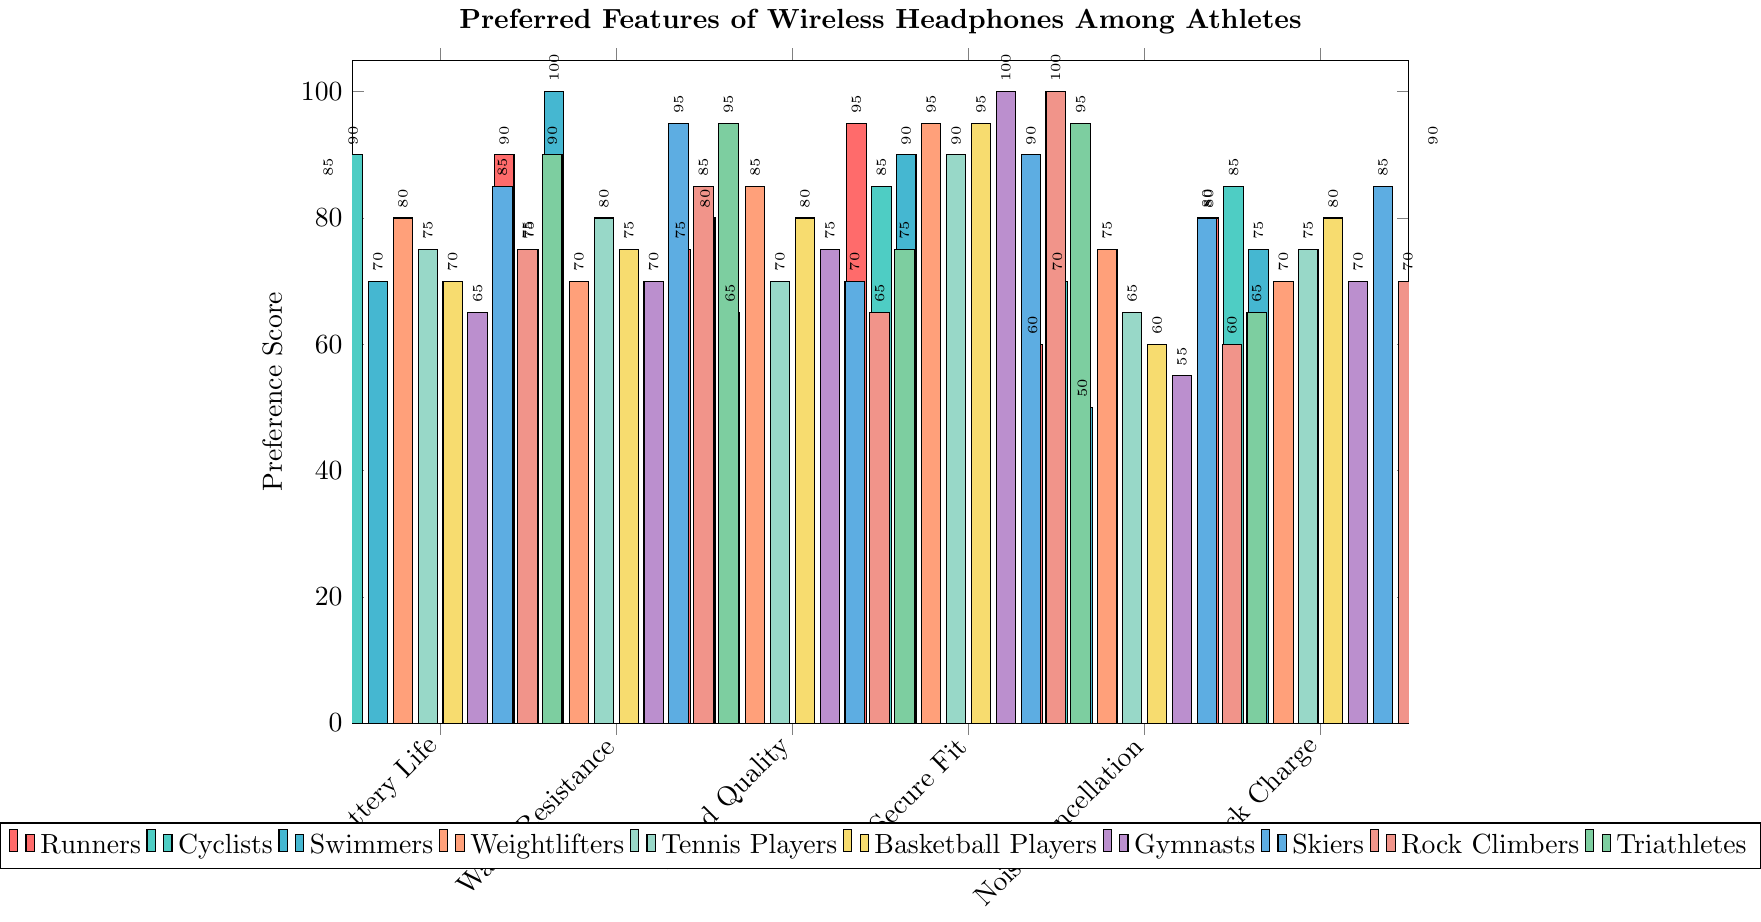what are the top 3 most valued features among runners? Examine the preference scores of runners for each feature and identify the top three highest scores, which are Secure Fit (95), Water Resistance (90), and Battery Life (85).
Answer: Secure Fit, Water Resistance, Battery Life Which feature is valued the least by swimmers? Look at the preference scores of swimmers for each feature and identify the lowest score, which is Noise Cancellation (50).
Answer: Noise Cancellation Which athlete types value quick charge equally? Compare the quick charge preference scores across athlete types, and identify those with equal values. Basketball Players, Swimmers, and Tennis Players all have a Quick Charge score of 75.
Answer: Basketball Players, Swimmers, Tennis Players What's the average preference score for noise cancellation among all athletes? Sum the Noise Cancellation scores for all athletes and divide by the number of athletes: (60+70+50+75+65+60+55+80+60+65)/10 = 64
Answer: 64 For which feature is the preference difference between weightlifters and runners the highest? Calculate the absolute differences between weightlifters and runners for each feature: Battery Life (80-85=5), Water Resistance (70-90=20), Sound Quality (85-75=10), Secure Fit (95-95=0), Noise Cancellation (75-60=15), and Quick Charge (70-80=10). The highest difference is found in Water Resistance, with a difference of 20.
Answer: Water Resistance How many athlete types have a preference score of 90 or higher for water resistance? Count the number of athlete types with Water Resistance scores of 90 or higher: Runners (90), Swimmers (100), Skiers (95), and Triathletes (95) make 4 types.
Answer: 4 What is the total preference score for Sound Quality among Gymnasts, Swimmers, and Cyclists? Sum the Sound Quality scores for Gymnasts (75), Swimmers (65), and Cyclists (80), 75 + 65 + 80 = 220.
Answer: 220 Which athlete type values Secure Fit the most? Identify the athlete type with the highest Secure Fit score, which is Gymnasts and Rock Climbers both with a score of 100.
Answer: Gymnasts, Rock Climbers What is the median preference score for Quick Charge among all athletes? Arrange the Quick Charge scores in ascending order: 70, 70, 70, 75, 75, 80, 80, 85, 85, 90. The median is the average of the 5th and 6th values (75 and 80): (75+80)/2 = 77.5
Answer: 77.5 